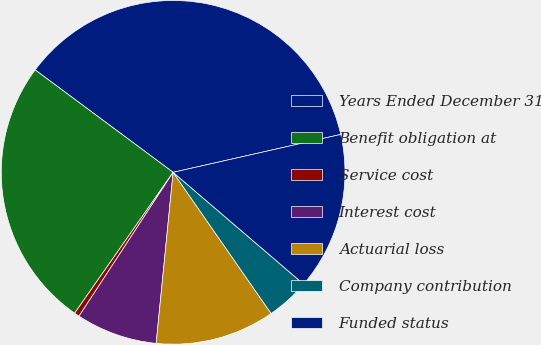Convert chart. <chart><loc_0><loc_0><loc_500><loc_500><pie_chart><fcel>Years Ended December 31<fcel>Benefit obligation at<fcel>Service cost<fcel>Interest cost<fcel>Actuarial loss<fcel>Company contribution<fcel>Funded status<nl><fcel>36.3%<fcel>25.45%<fcel>0.49%<fcel>7.65%<fcel>11.23%<fcel>4.07%<fcel>14.81%<nl></chart> 